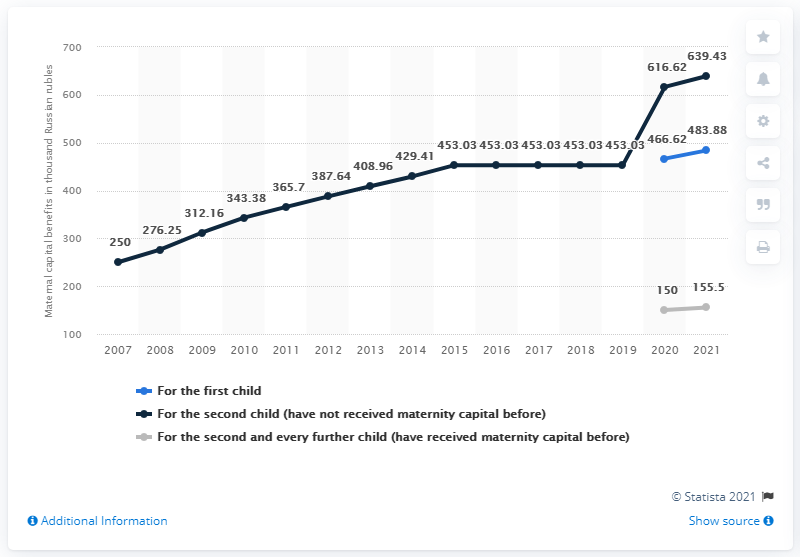Mention a couple of crucial points in this snapshot. A family in Russia is expected to receive their first child in 2021. 